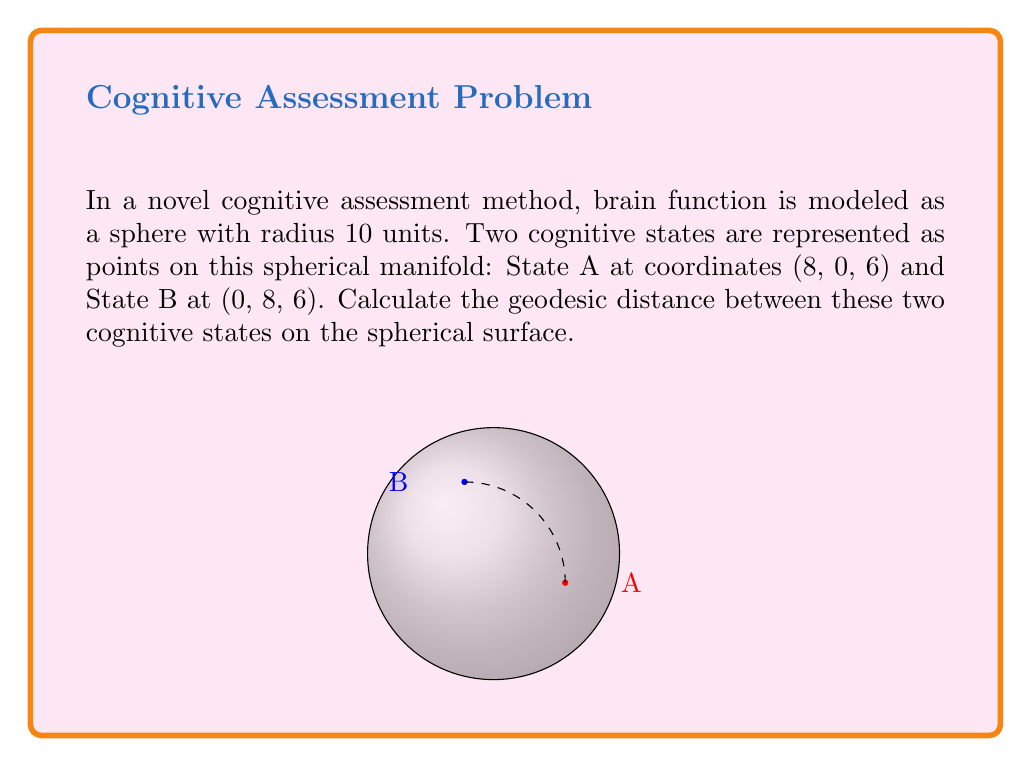Provide a solution to this math problem. To solve this problem, we'll follow these steps:

1) First, recall that the geodesic distance between two points on a sphere is given by the arc length of the great circle passing through these points.

2) The formula for geodesic distance $d$ on a sphere of radius $r$ is:

   $$d = r \arccos\left(\frac{x_1x_2 + y_1y_2 + z_1z_2}{r^2}\right)$$

   where $(x_1,y_1,z_1)$ and $(x_2,y_2,z_2)$ are the coordinates of the two points.

3) In our case:
   - $r = 10$
   - Point A: $(x_1,y_1,z_1) = (8,0,6)$
   - Point B: $(x_2,y_2,z_2) = (0,8,6)$

4) Let's substitute these into the formula:

   $$d = 10 \arccos\left(\frac{(8)(0) + (0)(8) + (6)(6)}{10^2}\right)$$

5) Simplify:

   $$d = 10 \arccos\left(\frac{36}{100}\right) = 10 \arccos(0.36)$$

6) Using a calculator or computer:

   $$d \approx 10 \times 1.2050 = 12.050$$

Thus, the geodesic distance between the two cognitive states is approximately 12.050 units on the spherical surface.
Answer: $12.050$ units 